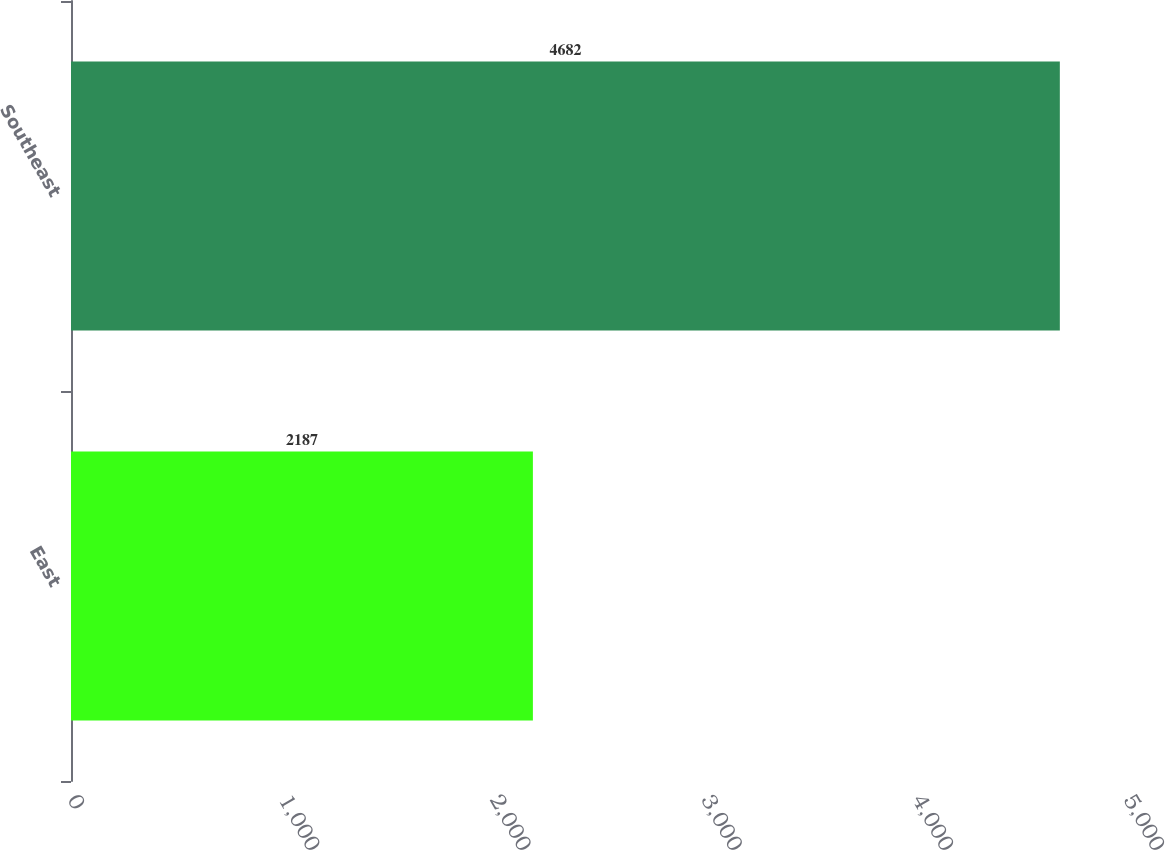Convert chart. <chart><loc_0><loc_0><loc_500><loc_500><bar_chart><fcel>East<fcel>Southeast<nl><fcel>2187<fcel>4682<nl></chart> 